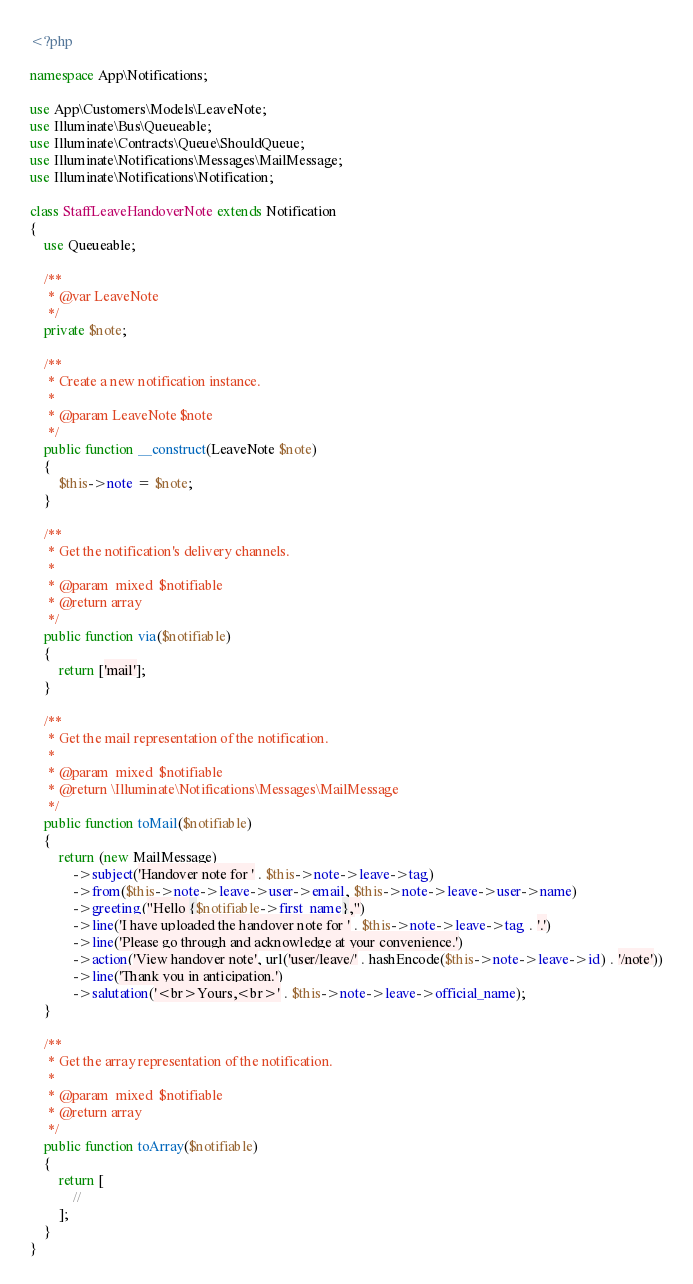Convert code to text. <code><loc_0><loc_0><loc_500><loc_500><_PHP_><?php

namespace App\Notifications;

use App\Customers\Models\LeaveNote;
use Illuminate\Bus\Queueable;
use Illuminate\Contracts\Queue\ShouldQueue;
use Illuminate\Notifications\Messages\MailMessage;
use Illuminate\Notifications\Notification;

class StaffLeaveHandoverNote extends Notification
{
    use Queueable;

    /**
     * @var LeaveNote
     */
    private $note;

    /**
     * Create a new notification instance.
     *
     * @param LeaveNote $note
     */
    public function __construct(LeaveNote $note)
    {
        $this->note = $note;
    }

    /**
     * Get the notification's delivery channels.
     *
     * @param  mixed  $notifiable
     * @return array
     */
    public function via($notifiable)
    {
        return ['mail'];
    }

    /**
     * Get the mail representation of the notification.
     *
     * @param  mixed  $notifiable
     * @return \Illuminate\Notifications\Messages\MailMessage
     */
    public function toMail($notifiable)
    {
        return (new MailMessage)
            ->subject('Handover note for ' . $this->note->leave->tag)
            ->from($this->note->leave->user->email, $this->note->leave->user->name)
            ->greeting("Hello {$notifiable->first_name},")
            ->line('I have uploaded the handover note for ' . $this->note->leave->tag . '.')
            ->line('Please go through and acknowledge at your convenience.')
            ->action('View handover note', url('user/leave/' . hashEncode($this->note->leave->id) . '/note'))
            ->line('Thank you in anticipation.')
            ->salutation('<br>Yours,<br>' . $this->note->leave->official_name);
    }

    /**
     * Get the array representation of the notification.
     *
     * @param  mixed  $notifiable
     * @return array
     */
    public function toArray($notifiable)
    {
        return [
            //
        ];
    }
}
</code> 